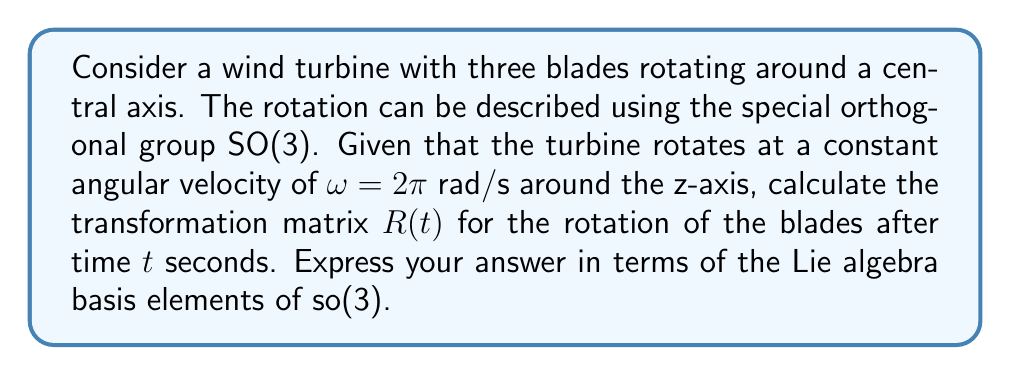Teach me how to tackle this problem. To solve this problem, we'll follow these steps:

1) First, recall that the Lie algebra so(3) of SO(3) has the following basis elements:

   $$E_1 = \begin{pmatrix} 0 & 0 & 0 \\ 0 & 0 & -1 \\ 0 & 1 & 0 \end{pmatrix}, 
     E_2 = \begin{pmatrix} 0 & 0 & 1 \\ 0 & 0 & 0 \\ -1 & 0 & 0 \end{pmatrix}, 
     E_3 = \begin{pmatrix} 0 & -1 & 0 \\ 1 & 0 & 0 \\ 0 & 0 & 0 \end{pmatrix}$$

2) The rotation is around the z-axis, which corresponds to $E_3$.

3) The angular velocity vector in the Lie algebra is:

   $$\omega = 2\pi E_3$$

4) The rotation matrix after time $t$ is given by the matrix exponential:

   $$R(t) = \exp(t\omega) = \exp(2\pi t E_3)$$

5) We can compute this exponential using Rodrigues' formula:

   $$\exp(θE_3) = I + \sin(θ)E_3 + (1-\cos(θ))E_3^2$$

   where $θ = 2\pi t$ and $I$ is the 3x3 identity matrix.

6) Calculating $E_3^2$:

   $$E_3^2 = \begin{pmatrix} -1 & 0 & 0 \\ 0 & -1 & 0 \\ 0 & 0 & 0 \end{pmatrix}$$

7) Substituting into Rodrigues' formula:

   $$R(t) = \begin{pmatrix} 1 & 0 & 0 \\ 0 & 1 & 0 \\ 0 & 0 & 1 \end{pmatrix} + 
            \sin(2\pi t)\begin{pmatrix} 0 & -1 & 0 \\ 1 & 0 & 0 \\ 0 & 0 & 0 \end{pmatrix} + 
            (1-\cos(2\pi t))\begin{pmatrix} -1 & 0 & 0 \\ 0 & -1 & 0 \\ 0 & 0 & 0 \end{pmatrix}$$

8) Simplifying:

   $$R(t) = \begin{pmatrix} \cos(2\pi t) & -\sin(2\pi t) & 0 \\ \sin(2\pi t) & \cos(2\pi t) & 0 \\ 0 & 0 & 1 \end{pmatrix}$$

9) This can be expressed in terms of the Lie algebra basis elements as:

   $$R(t) = I + \sin(2\pi t)E_3 + (1-\cos(2\pi t))E_3^2$$
Answer: $$R(t) = I + \sin(2\pi t)E_3 + (1-\cos(2\pi t))E_3^2$$
where $I$ is the 3x3 identity matrix and $E_3 = \begin{pmatrix} 0 & -1 & 0 \\ 1 & 0 & 0 \\ 0 & 0 & 0 \end{pmatrix}$ 